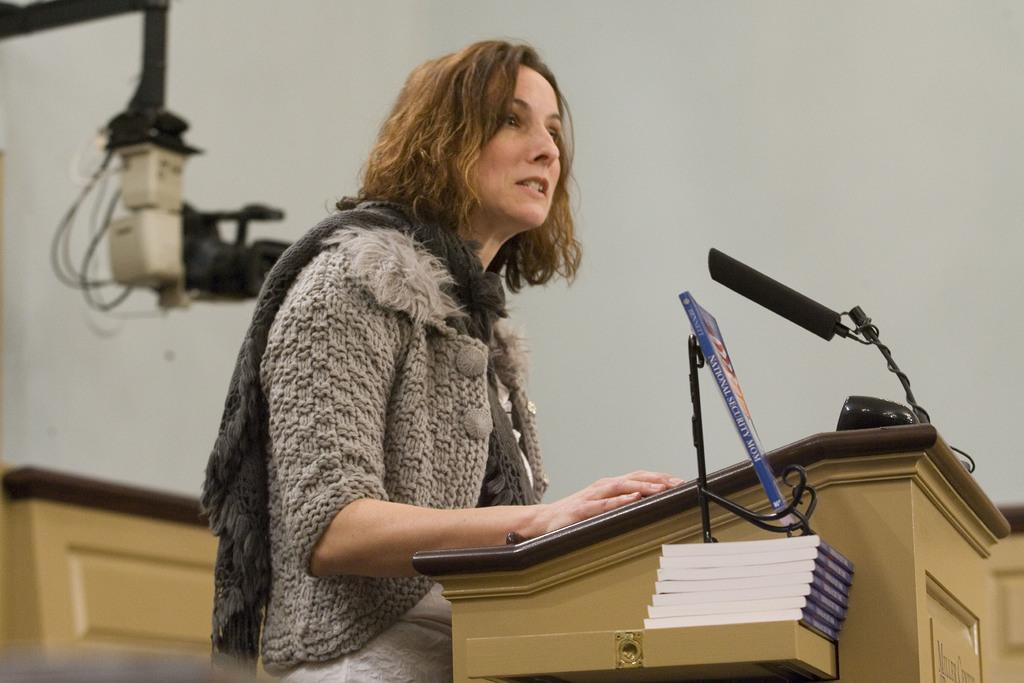Who is the main subject in the image? There is a woman in the center of the image. What is the woman doing in the image? The woman is talking. What is in front of the woman? There is a podium, a microphone, and a box in front of the woman. What can be seen in the background of the image? There is a camera, objects, and a wall in the background of the image. What type of lock is used to secure the microphone in the image? There is no lock present in the image, and the microphone is not secured with a lock. 